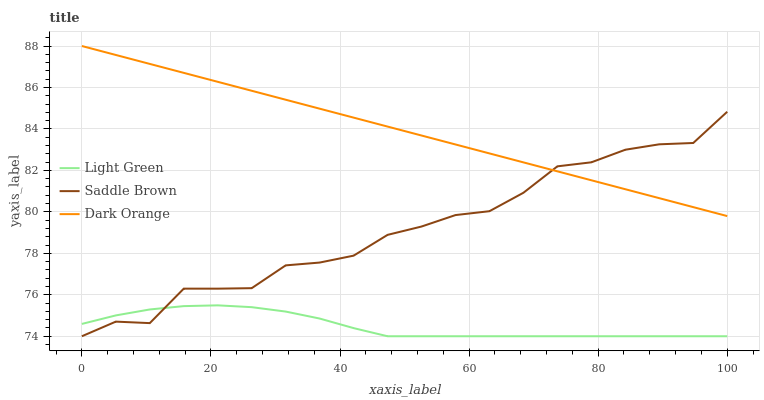Does Light Green have the minimum area under the curve?
Answer yes or no. Yes. Does Dark Orange have the maximum area under the curve?
Answer yes or no. Yes. Does Saddle Brown have the minimum area under the curve?
Answer yes or no. No. Does Saddle Brown have the maximum area under the curve?
Answer yes or no. No. Is Dark Orange the smoothest?
Answer yes or no. Yes. Is Saddle Brown the roughest?
Answer yes or no. Yes. Is Light Green the smoothest?
Answer yes or no. No. Is Light Green the roughest?
Answer yes or no. No. Does Saddle Brown have the lowest value?
Answer yes or no. Yes. Does Dark Orange have the highest value?
Answer yes or no. Yes. Does Saddle Brown have the highest value?
Answer yes or no. No. Is Light Green less than Dark Orange?
Answer yes or no. Yes. Is Dark Orange greater than Light Green?
Answer yes or no. Yes. Does Saddle Brown intersect Dark Orange?
Answer yes or no. Yes. Is Saddle Brown less than Dark Orange?
Answer yes or no. No. Is Saddle Brown greater than Dark Orange?
Answer yes or no. No. Does Light Green intersect Dark Orange?
Answer yes or no. No. 